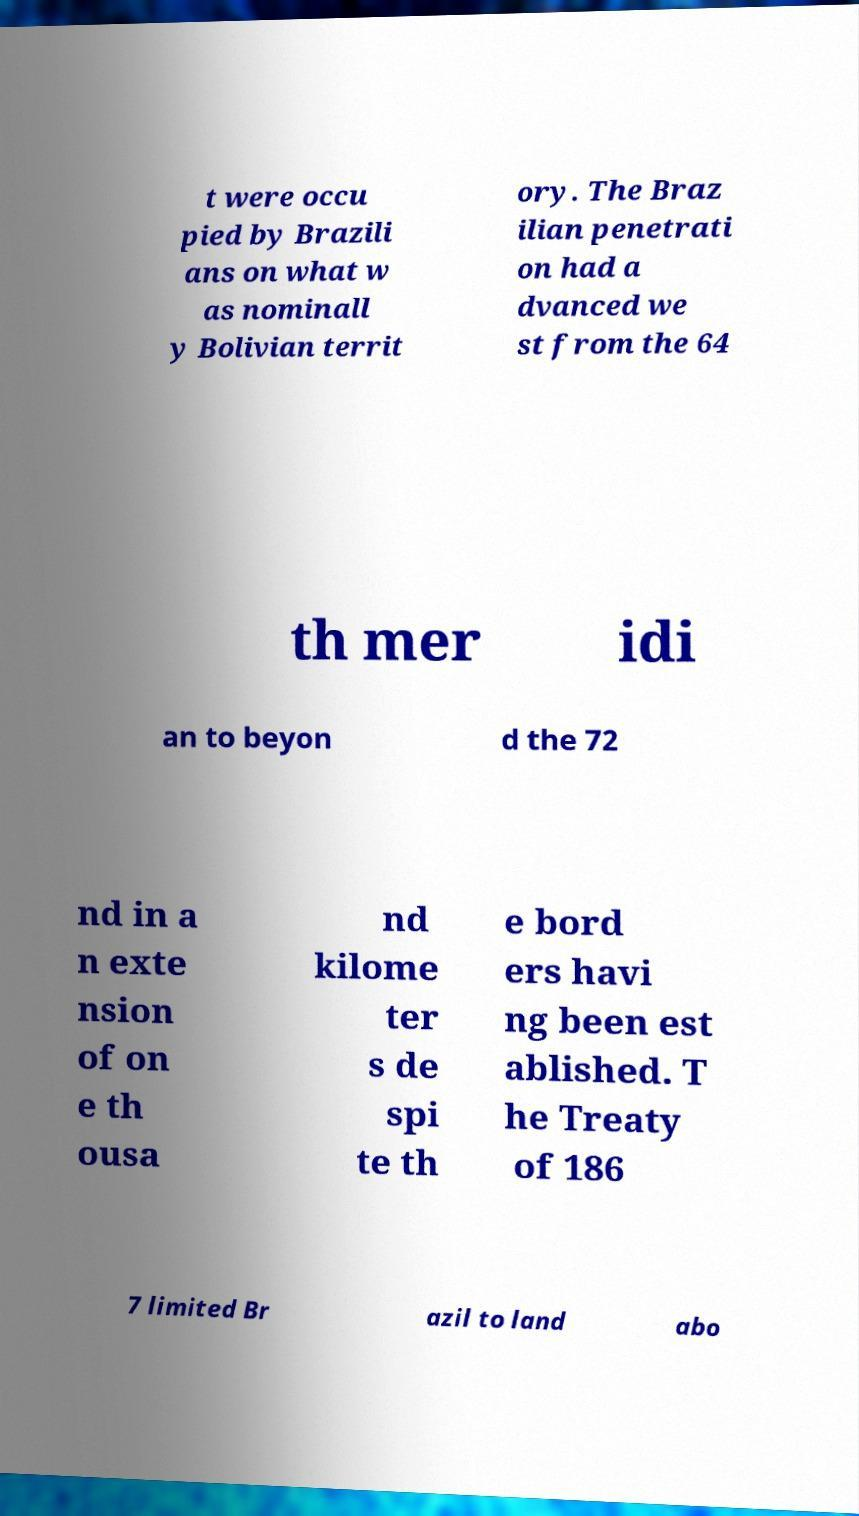What messages or text are displayed in this image? I need them in a readable, typed format. t were occu pied by Brazili ans on what w as nominall y Bolivian territ ory. The Braz ilian penetrati on had a dvanced we st from the 64 th mer idi an to beyon d the 72 nd in a n exte nsion of on e th ousa nd kilome ter s de spi te th e bord ers havi ng been est ablished. T he Treaty of 186 7 limited Br azil to land abo 